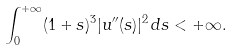Convert formula to latex. <formula><loc_0><loc_0><loc_500><loc_500>\int _ { 0 } ^ { + \infty } ( 1 + s ) ^ { 3 } | u ^ { \prime \prime } ( s ) | ^ { 2 } \, d s < + \infty .</formula> 